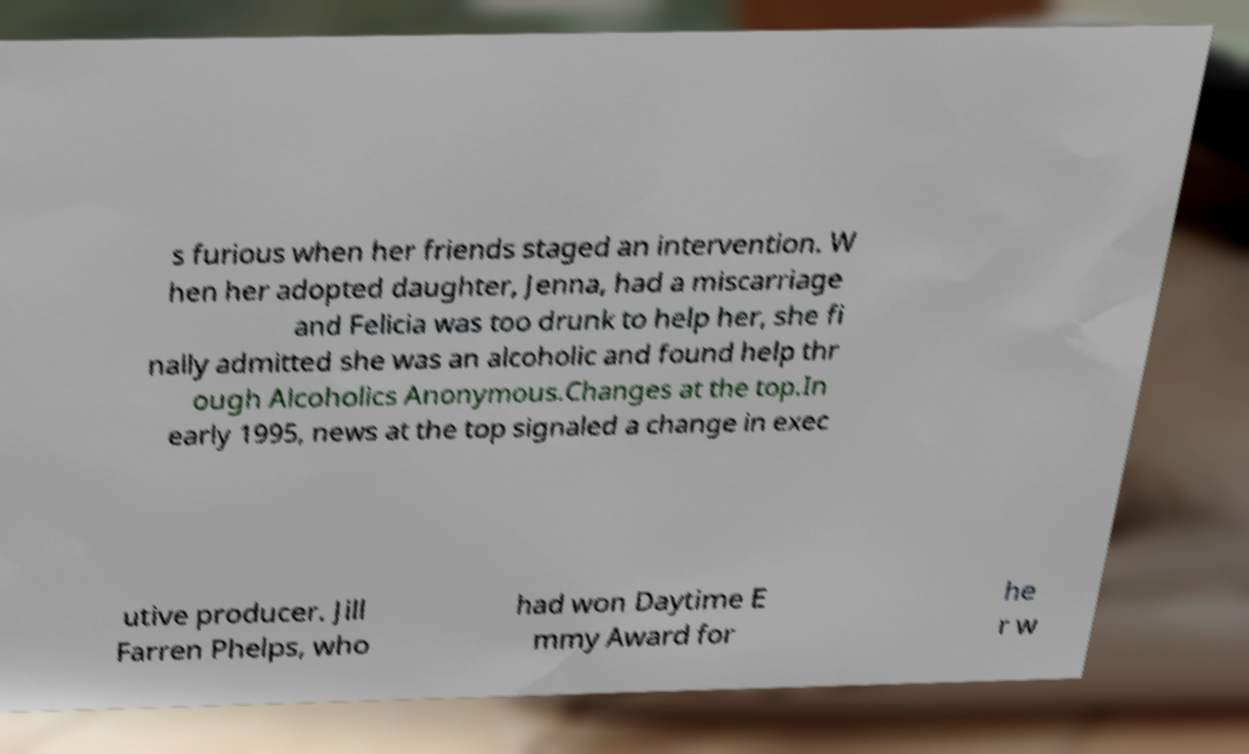What messages or text are displayed in this image? I need them in a readable, typed format. s furious when her friends staged an intervention. W hen her adopted daughter, Jenna, had a miscarriage and Felicia was too drunk to help her, she fi nally admitted she was an alcoholic and found help thr ough Alcoholics Anonymous.Changes at the top.In early 1995, news at the top signaled a change in exec utive producer. Jill Farren Phelps, who had won Daytime E mmy Award for he r w 